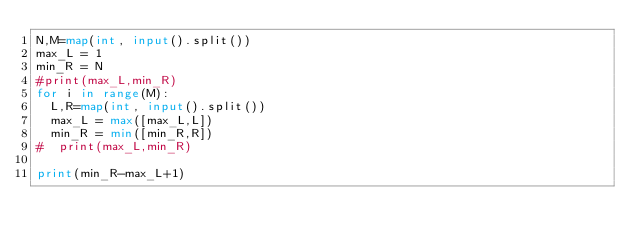Convert code to text. <code><loc_0><loc_0><loc_500><loc_500><_Python_>N,M=map(int, input().split())
max_L = 1
min_R = N
#print(max_L,min_R)
for i in range(M):
  L,R=map(int, input().split())
  max_L = max([max_L,L])
  min_R = min([min_R,R])
#  print(max_L,min_R)

print(min_R-max_L+1)</code> 